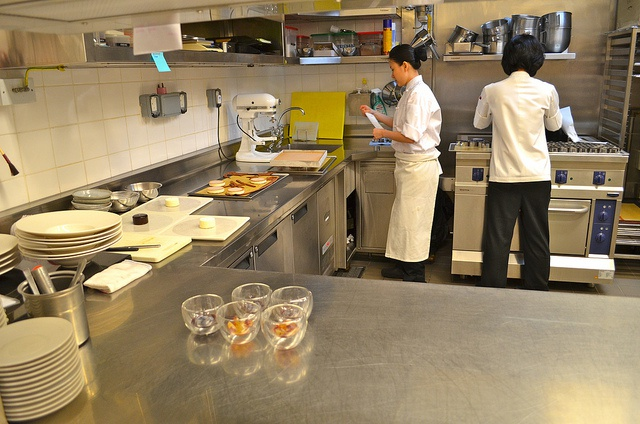Describe the objects in this image and their specific colors. I can see people in gray, black, ivory, and tan tones, oven in gray, tan, olive, and black tones, people in gray, tan, ivory, and black tones, bowl in gray, tan, and black tones, and cup in gray, tan, and khaki tones in this image. 